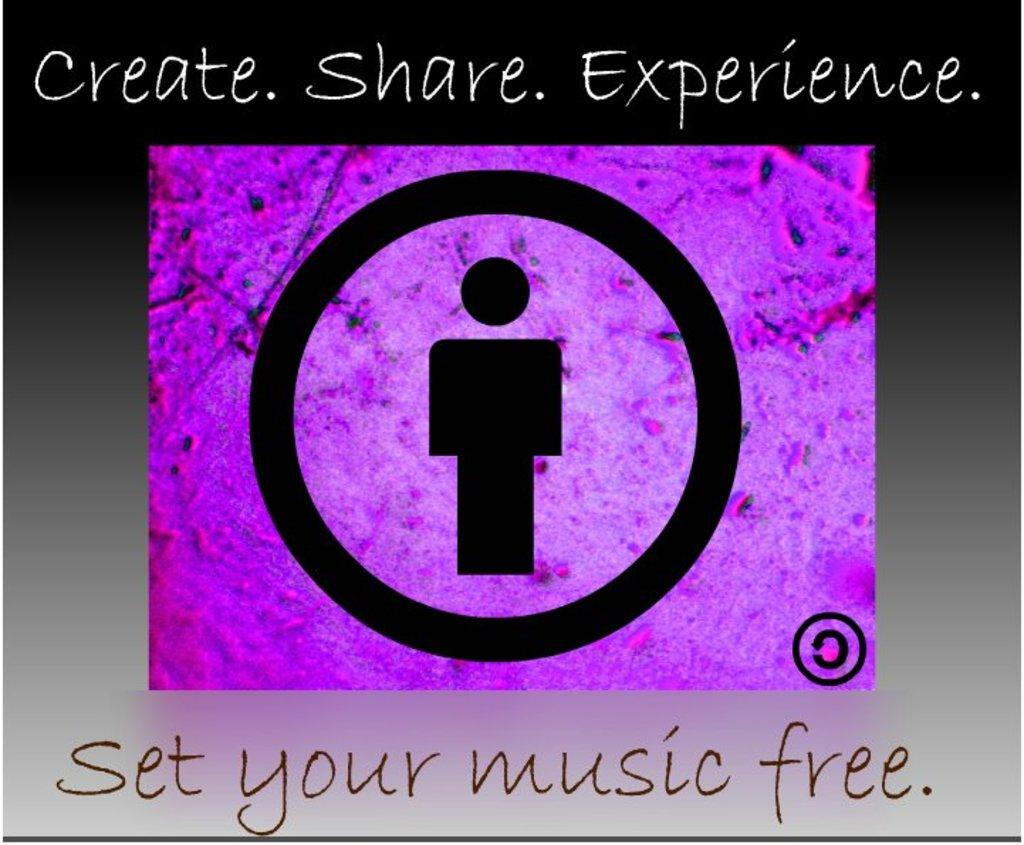<image>
Provide a brief description of the given image. An ad imploring the reader to set their music free. 